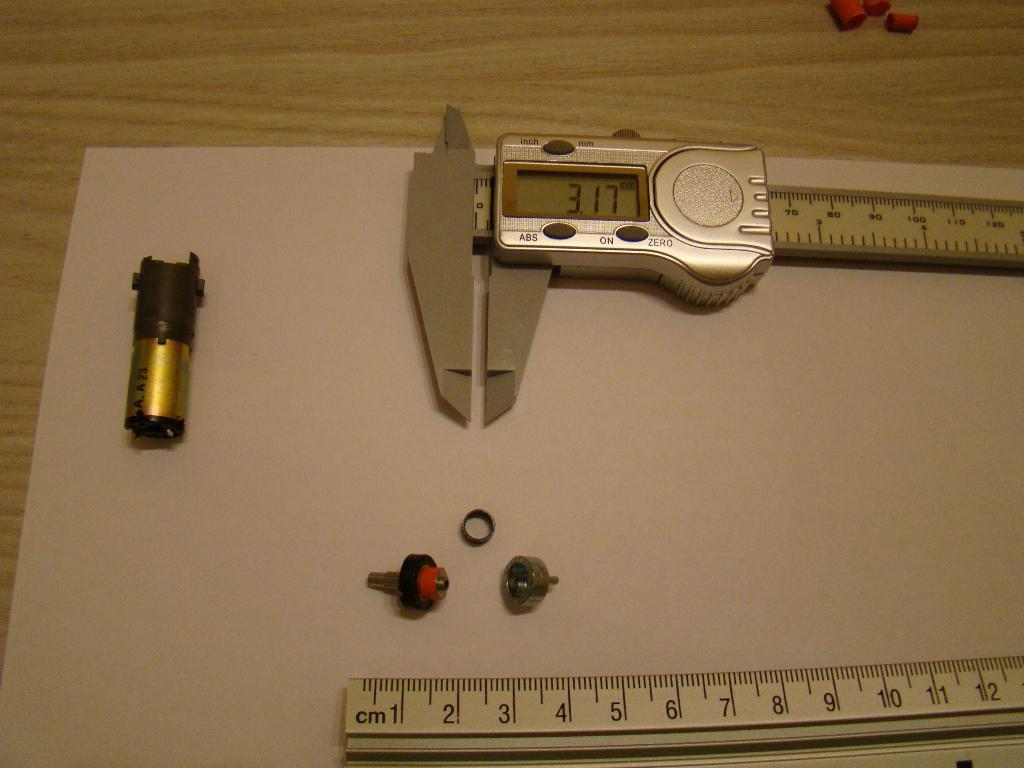<image>
Describe the image concisely. Ruler measuring an object with a screen that says 317. 